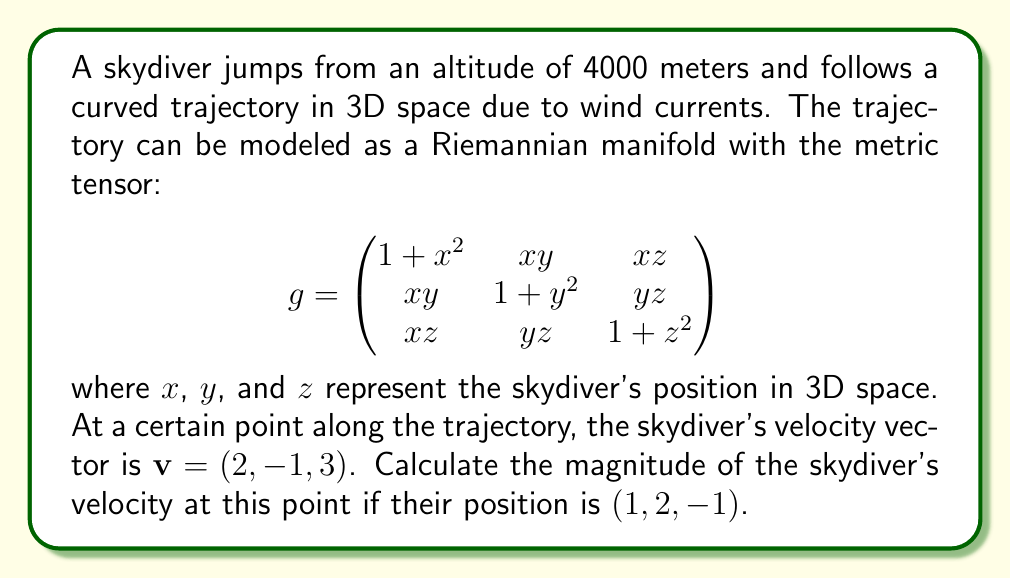Give your solution to this math problem. To solve this problem, we need to use the concept of Riemannian manifolds and the given metric tensor. The magnitude of a vector in a Riemannian manifold is calculated using the metric tensor. Here's a step-by-step approach:

1) The magnitude of a vector $\mathbf{v}$ in a Riemannian manifold with metric tensor $g$ is given by:

   $$\|\mathbf{v}\| = \sqrt{\mathbf{v}^T g \mathbf{v}}$$

2) We need to evaluate the metric tensor at the given position $(1, 2, -1)$:

   $$g_{(1,2,-1)} = \begin{pmatrix}
   1 + 1^2 & 1 \cdot 2 & 1 \cdot (-1) \\
   1 \cdot 2 & 1 + 2^2 & 2 \cdot (-1) \\
   1 \cdot (-1) & 2 \cdot (-1) & 1 + (-1)^2
   \end{pmatrix} = \begin{pmatrix}
   2 & 2 & -1 \\
   2 & 5 & -2 \\
   -1 & -2 & 2
   \end{pmatrix}$$

3) Now, we can calculate $\mathbf{v}^T g \mathbf{v}$:

   $$\mathbf{v}^T g \mathbf{v} = \begin{pmatrix} 2 & -1 & 3 \end{pmatrix} \begin{pmatrix}
   2 & 2 & -1 \\
   2 & 5 & -2 \\
   -1 & -2 & 2
   \end{pmatrix} \begin{pmatrix} 2 \\ -1 \\ 3 \end{pmatrix}$$

4) Let's multiply this out:
   
   $$\begin{aligned}
   \mathbf{v}^T g \mathbf{v} &= \begin{pmatrix} 2 & -1 & 3 \end{pmatrix} \begin{pmatrix} 2(2) + 2(-1) + (-1)(3) \\ 2(2) + 5(-1) + (-2)(3) \\ (-1)(2) + (-2)(-1) + 2(3) \end{pmatrix} \\
   &= \begin{pmatrix} 2 & -1 & 3 \end{pmatrix} \begin{pmatrix} 1 \\ -5 \\ 4 \end{pmatrix} \\
   &= 2(1) + (-1)(-5) + 3(4) \\
   &= 2 + 5 + 12 \\
   &= 19
   \end{aligned}$$

5) Finally, we can calculate the magnitude:

   $$\|\mathbf{v}\| = \sqrt{\mathbf{v}^T g \mathbf{v}} = \sqrt{19}$$

Thus, the magnitude of the skydiver's velocity at the given point is $\sqrt{19}$.
Answer: The magnitude of the skydiver's velocity is $\sqrt{19}$ units. 